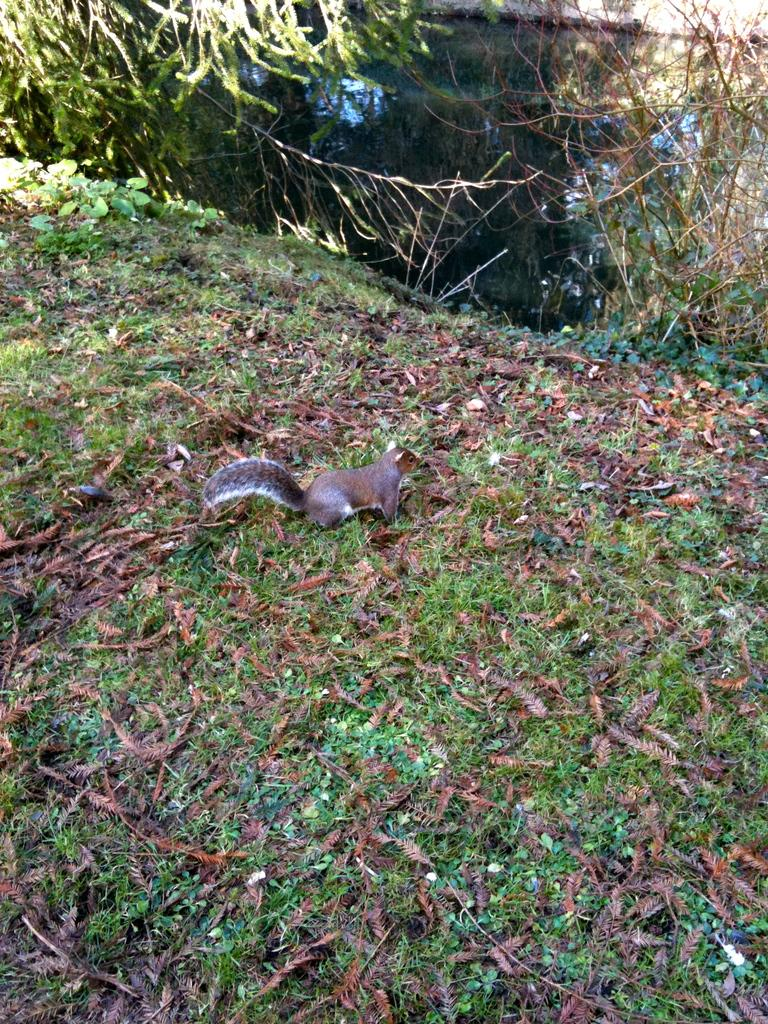What animal can be seen on the ground in the image? There is a squirrel on the ground in the image. What type of natural debris is present on the ground? Dried leaves are present on the ground in the image. What type of vegetation is visible on the ground? Plants are on the ground in the image. What can be seen at the top of the image? Water and branches of a tree are visible at the top of the image. Can you identify any specific plant in the image? Yes, there is a plant in the image. What type of leg is visible in the image? There is no leg visible in the image; the main subject is a squirrel, which has four legs, but they are not individually discernible in the image. 